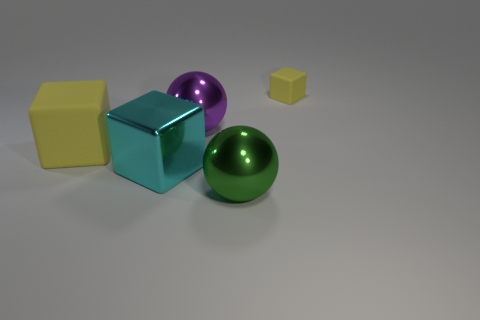How many objects are either spheres or yellow blocks on the right side of the green metallic thing?
Your response must be concise. 3. There is a thing that is in front of the tiny yellow rubber object and behind the large yellow cube; what shape is it?
Your response must be concise. Sphere. There is a cube that is behind the yellow rubber object to the left of the small yellow matte cube; what is its material?
Ensure brevity in your answer.  Rubber. Do the cube in front of the large yellow rubber thing and the purple object have the same material?
Give a very brief answer. Yes. There is a thing that is to the right of the green ball; how big is it?
Offer a terse response. Small. There is a yellow matte block in front of the small object; are there any metallic balls that are in front of it?
Your answer should be very brief. Yes. There is a big metal object that is behind the cyan shiny cube; does it have the same color as the matte cube to the left of the small yellow cube?
Your response must be concise. No. What is the color of the small rubber object?
Your answer should be very brief. Yellow. Are there any other things that have the same color as the shiny block?
Your response must be concise. No. What is the color of the cube that is both left of the tiny thing and behind the cyan thing?
Provide a short and direct response. Yellow. 